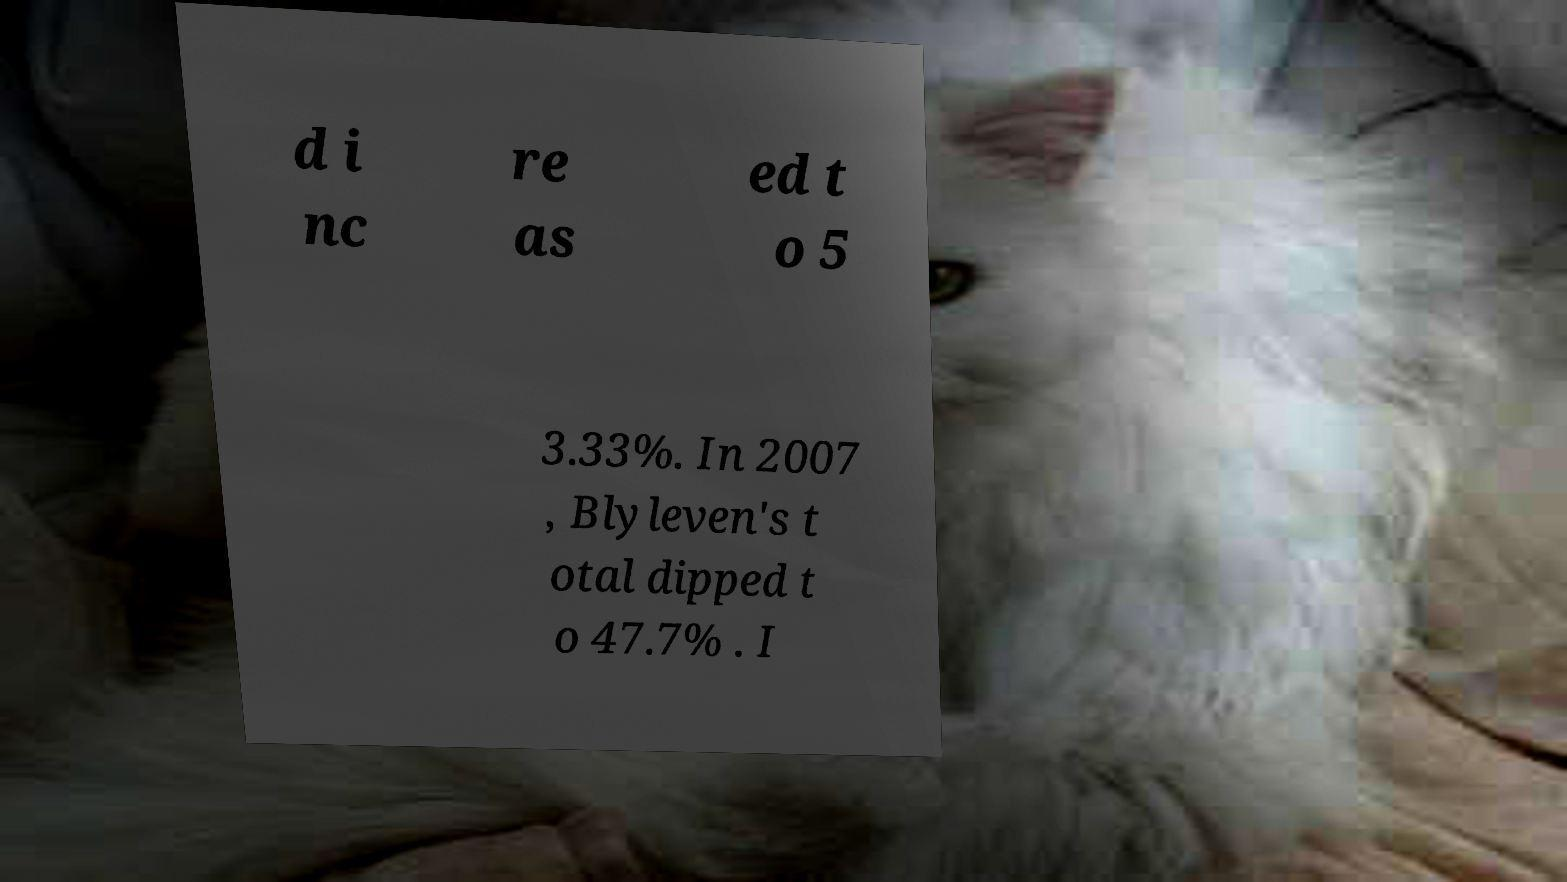Can you accurately transcribe the text from the provided image for me? d i nc re as ed t o 5 3.33%. In 2007 , Blyleven's t otal dipped t o 47.7% . I 